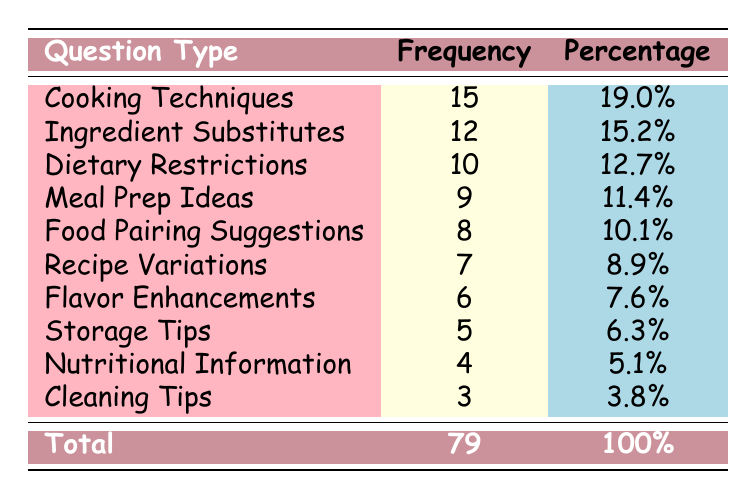What's the frequency of questions related to Cooking Techniques? The table lists Cooking Techniques with a frequency of 15, meaning this type of question was asked 15 times during the live cooking segments.
Answer: 15 Which question type has the lowest frequency? Cleaning Tips has the lowest frequency according to the table, with a count of 3.
Answer: 3 What is the combined frequency of questions about Ingredient Substitutes and Dietary Restrictions? The frequency for Ingredient Substitutes is 12 and for Dietary Restrictions is 10. Adding these gives 12 + 10 = 22.
Answer: 22 Is the frequency of Recipe Variations more than the frequency of Storage Tips? Recipe Variations has a frequency of 7, while Storage Tips has a frequency of 5. Since 7 is greater than 5, this statement is true.
Answer: Yes What percentage of the total questions received is related to Meal Prep Ideas? Meal Prep Ideas has a frequency of 9. The total number of questions is 79. Thus, the percentage is (9 / 79) * 100 ≈ 11.4%. This is directly given in the table.
Answer: 11.4% Which two question types have a frequency that combines to more than 20? Cooking Techniques (15) and Ingredient Substitutes (12) combined give 15 + 12 = 27, which is indeed more than 20. Therefore, these two types meet the criteria.
Answer: Yes What is the average frequency of all the question types listed? To find the average, we sum all the frequencies: (12 + 15 + 10 + 9 + 8 + 7 + 5 + 6 + 4 + 3) = 79. There are 10 question types. Thus, the average is 79 / 10 = 7.9.
Answer: 7.9 Is the frequency of Nutritional Information questions equal to that of Flavor Enhancements? The frequency for Nutritional Information is 4, while for Flavor Enhancements it is 6. Since 4 is not equal to 6, the answer is false.
Answer: No How many more times were questions about Cooking Techniques asked than questions about Cleaning Tips? Cooking Techniques has a frequency of 15 and Cleaning Tips has a frequency of 3. The difference is 15 - 3 = 12. This shows how many more times one type was asked compared to the other.
Answer: 12 